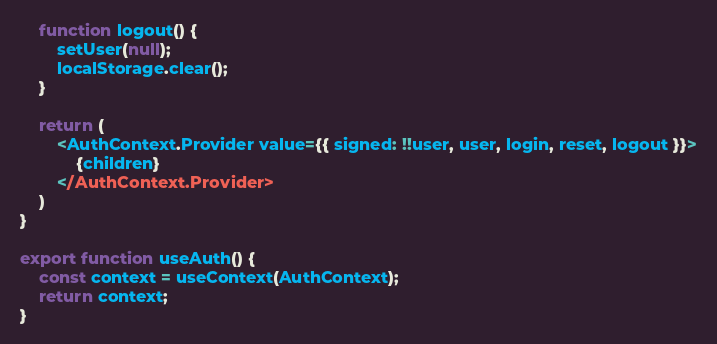Convert code to text. <code><loc_0><loc_0><loc_500><loc_500><_TypeScript_>    function logout() {
        setUser(null);
        localStorage.clear();
    }

    return (
        <AuthContext.Provider value={{ signed: !!user, user, login, reset, logout }}>
            {children}
        </AuthContext.Provider>
    )
}

export function useAuth() {
    const context = useContext(AuthContext);
    return context;
}</code> 